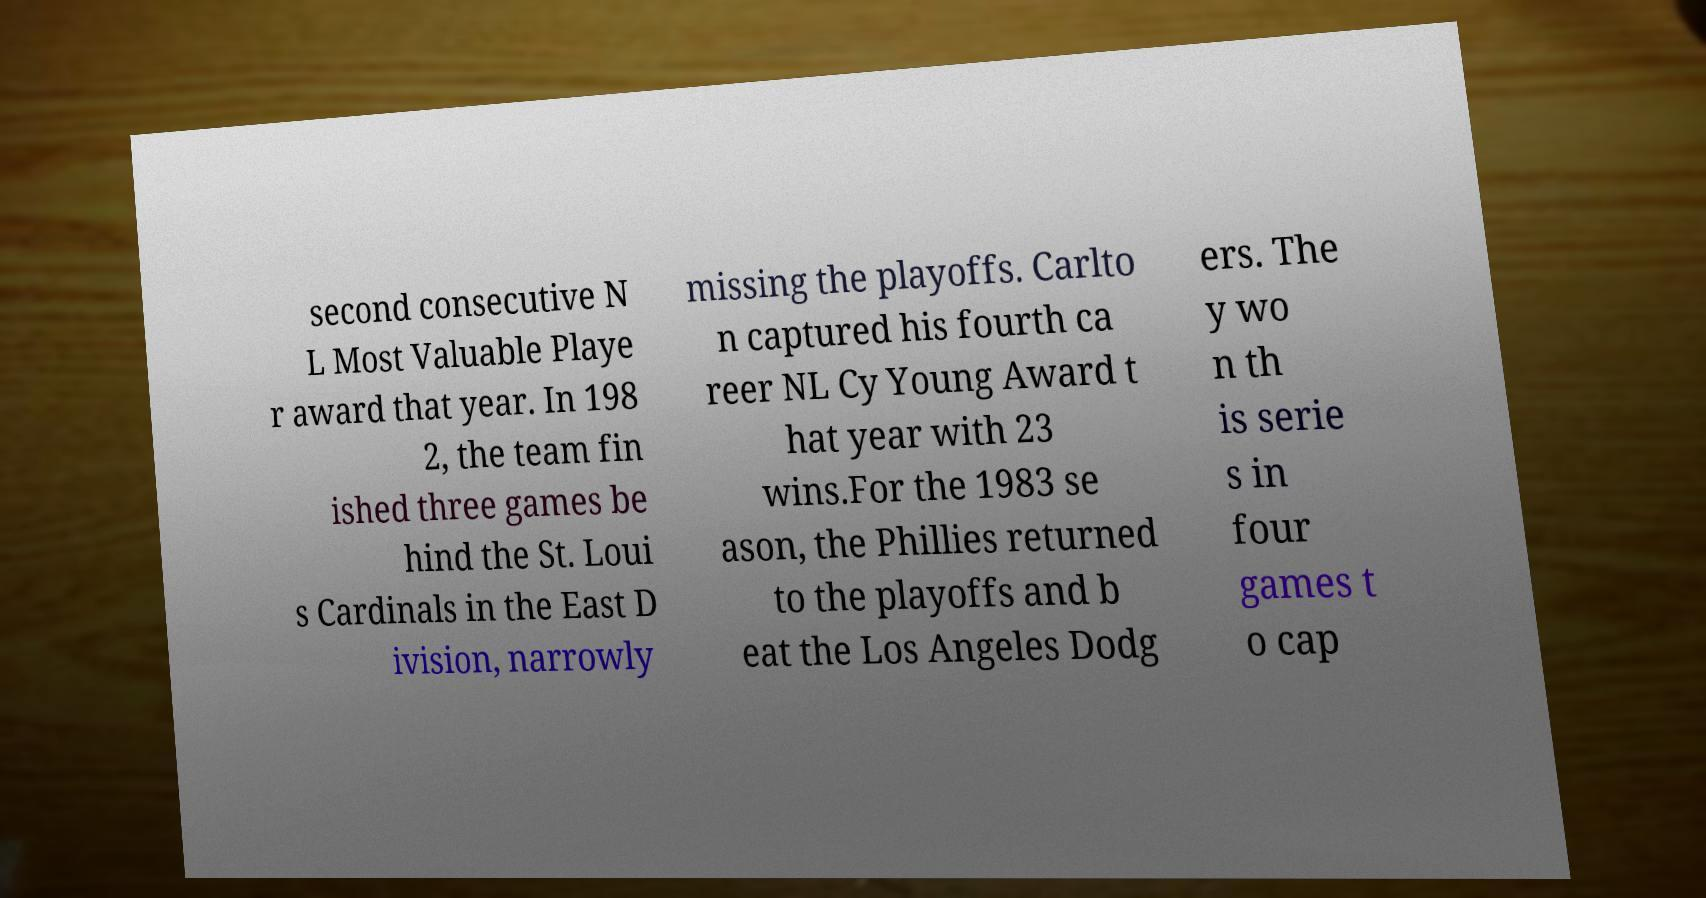I need the written content from this picture converted into text. Can you do that? second consecutive N L Most Valuable Playe r award that year. In 198 2, the team fin ished three games be hind the St. Loui s Cardinals in the East D ivision, narrowly missing the playoffs. Carlto n captured his fourth ca reer NL Cy Young Award t hat year with 23 wins.For the 1983 se ason, the Phillies returned to the playoffs and b eat the Los Angeles Dodg ers. The y wo n th is serie s in four games t o cap 